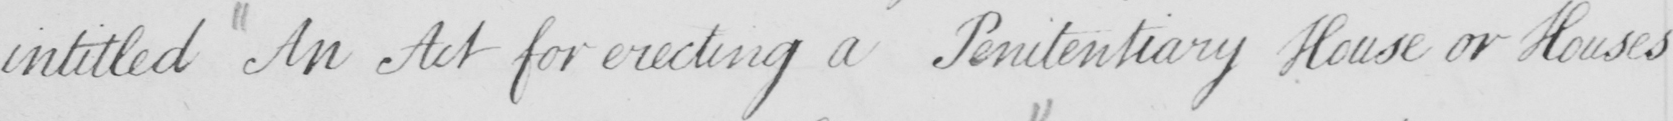Can you read and transcribe this handwriting? intitled An Act for erecting a Penitentiary House or Houses 